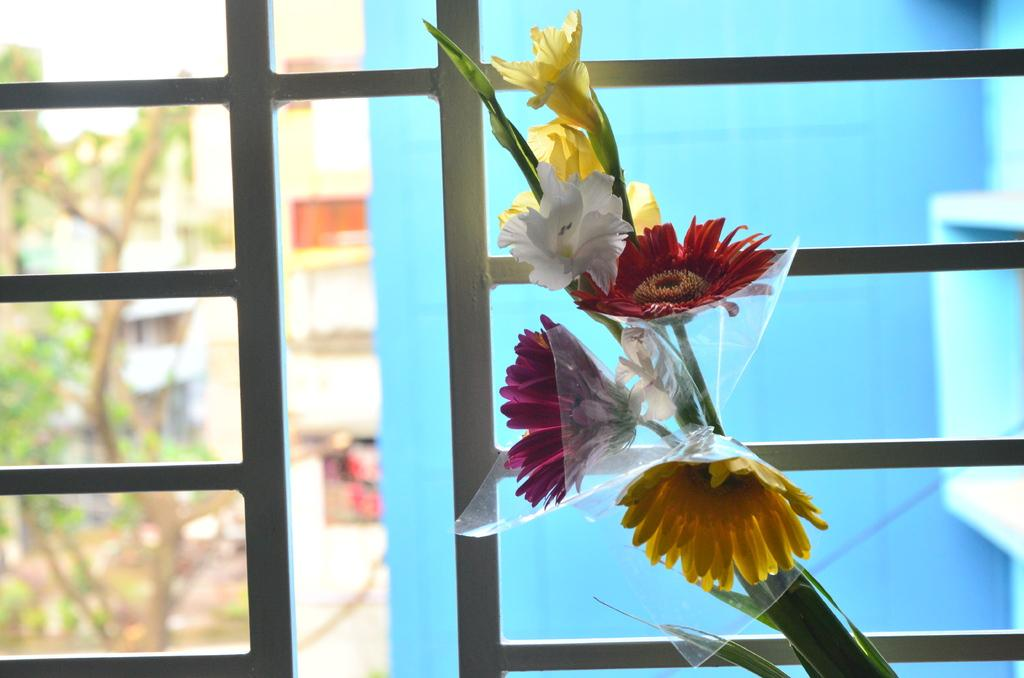What can be seen in the foreground of the image? There are flowers in the foreground of the image. What is located in the background of the image? There is a grill, trees, and buildings in the background of the image. Can you describe the vegetation visible in the image? The image features flowers in the foreground and trees in the background. What type of structures are visible in the background? Buildings are visible in the background of the image. How many giants are holding the flowers in the image? There are no giants present in the image; it features flowers in the foreground. What type of paper is being used to create the trees in the image? There is no paper used to create the trees in the image; they are real trees visible in the background. 